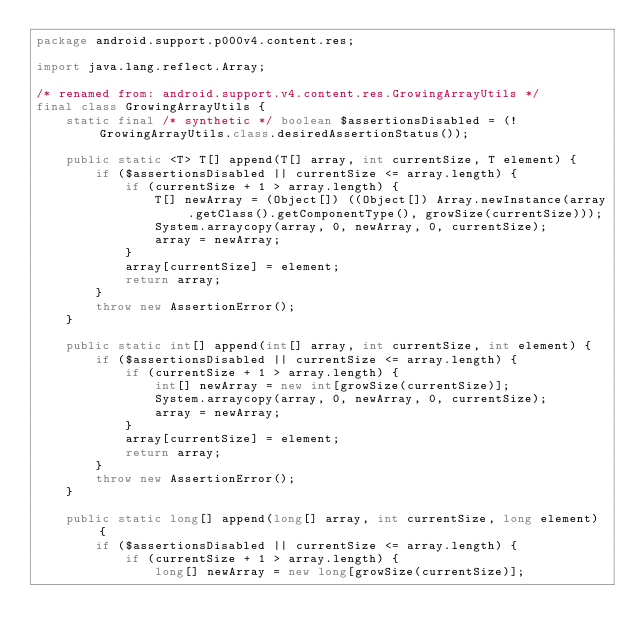Convert code to text. <code><loc_0><loc_0><loc_500><loc_500><_Java_>package android.support.p000v4.content.res;

import java.lang.reflect.Array;

/* renamed from: android.support.v4.content.res.GrowingArrayUtils */
final class GrowingArrayUtils {
    static final /* synthetic */ boolean $assertionsDisabled = (!GrowingArrayUtils.class.desiredAssertionStatus());

    public static <T> T[] append(T[] array, int currentSize, T element) {
        if ($assertionsDisabled || currentSize <= array.length) {
            if (currentSize + 1 > array.length) {
                T[] newArray = (Object[]) ((Object[]) Array.newInstance(array.getClass().getComponentType(), growSize(currentSize)));
                System.arraycopy(array, 0, newArray, 0, currentSize);
                array = newArray;
            }
            array[currentSize] = element;
            return array;
        }
        throw new AssertionError();
    }

    public static int[] append(int[] array, int currentSize, int element) {
        if ($assertionsDisabled || currentSize <= array.length) {
            if (currentSize + 1 > array.length) {
                int[] newArray = new int[growSize(currentSize)];
                System.arraycopy(array, 0, newArray, 0, currentSize);
                array = newArray;
            }
            array[currentSize] = element;
            return array;
        }
        throw new AssertionError();
    }

    public static long[] append(long[] array, int currentSize, long element) {
        if ($assertionsDisabled || currentSize <= array.length) {
            if (currentSize + 1 > array.length) {
                long[] newArray = new long[growSize(currentSize)];</code> 